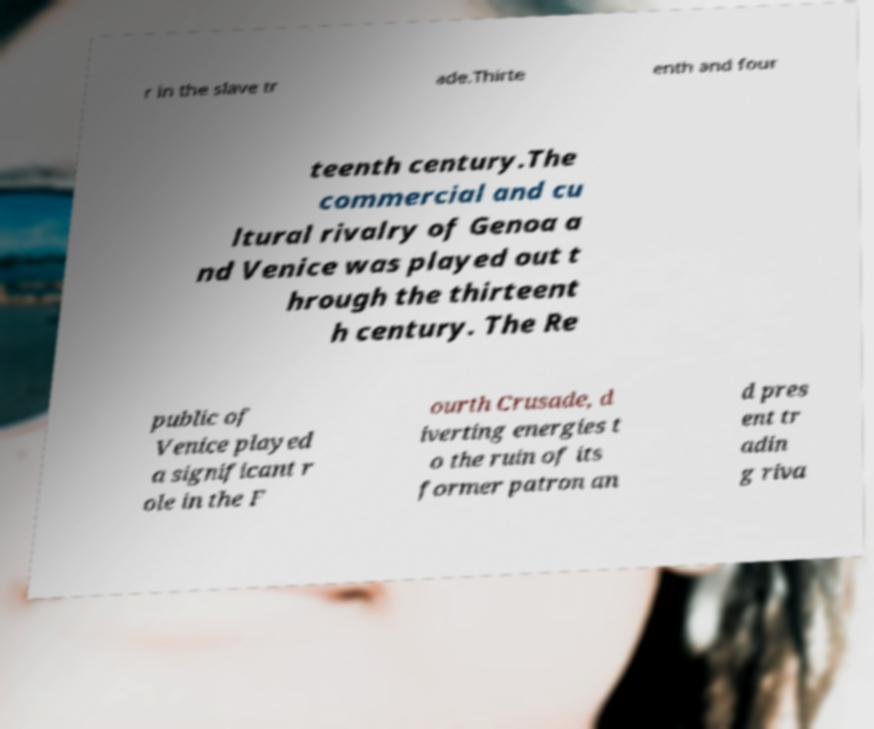Please read and relay the text visible in this image. What does it say? r in the slave tr ade.Thirte enth and four teenth century.The commercial and cu ltural rivalry of Genoa a nd Venice was played out t hrough the thirteent h century. The Re public of Venice played a significant r ole in the F ourth Crusade, d iverting energies t o the ruin of its former patron an d pres ent tr adin g riva 